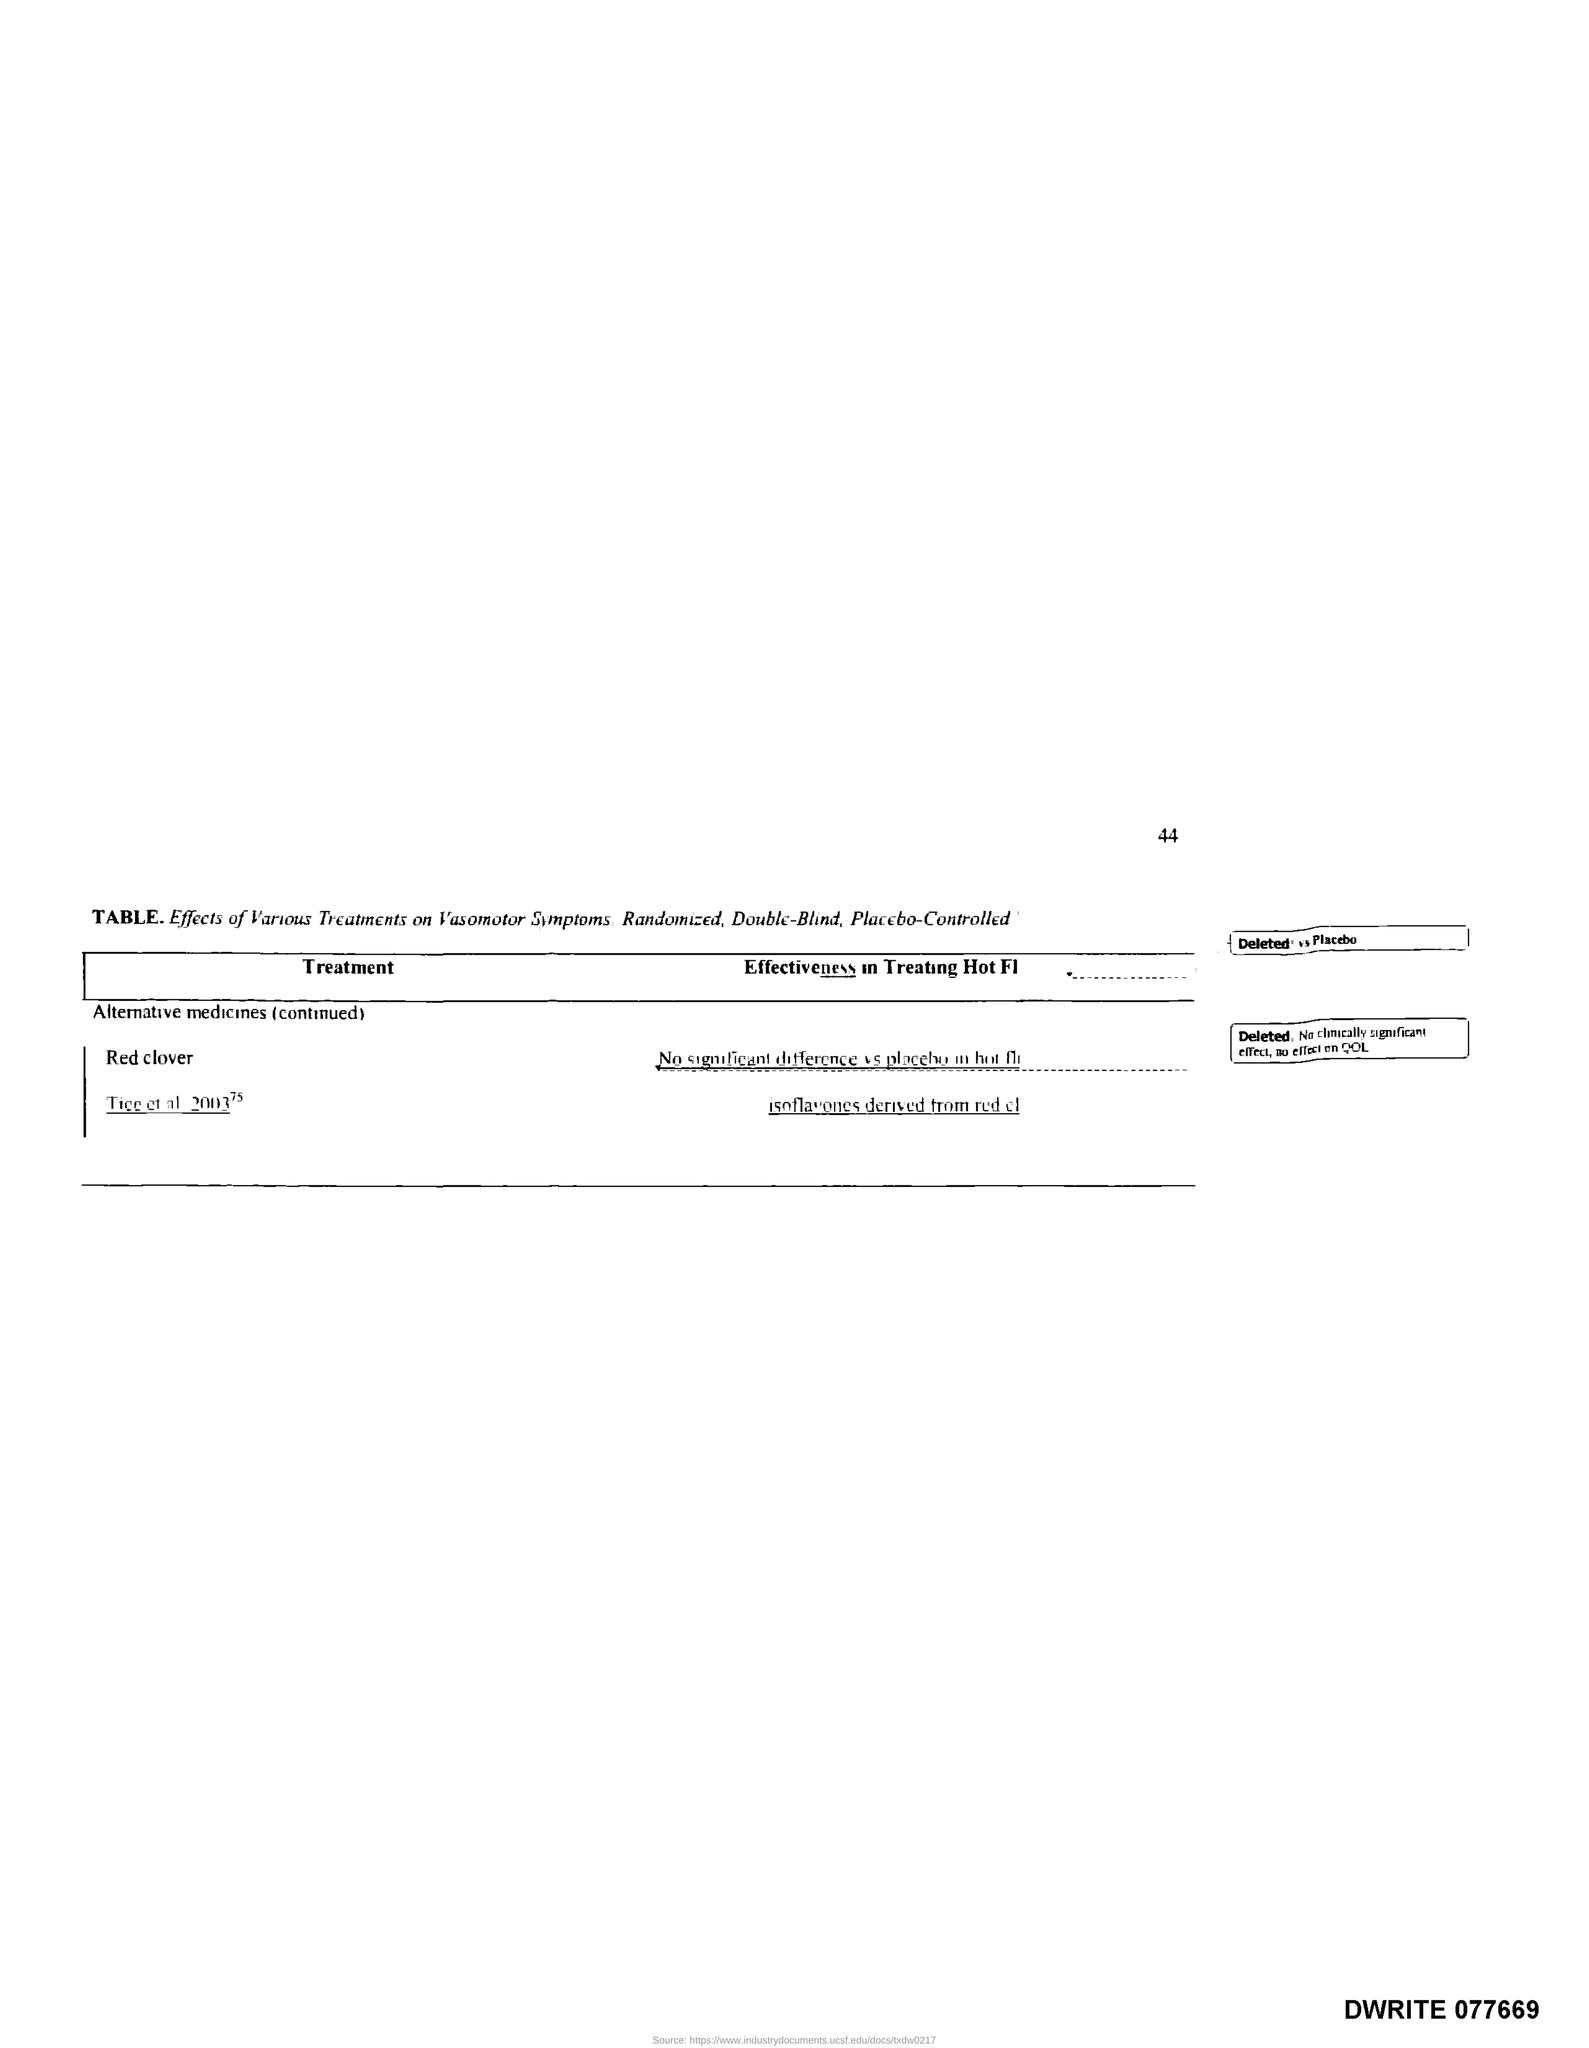What is the page number?
Provide a succinct answer. 44. What is the title of the first column of the table?
Make the answer very short. Treatment. 